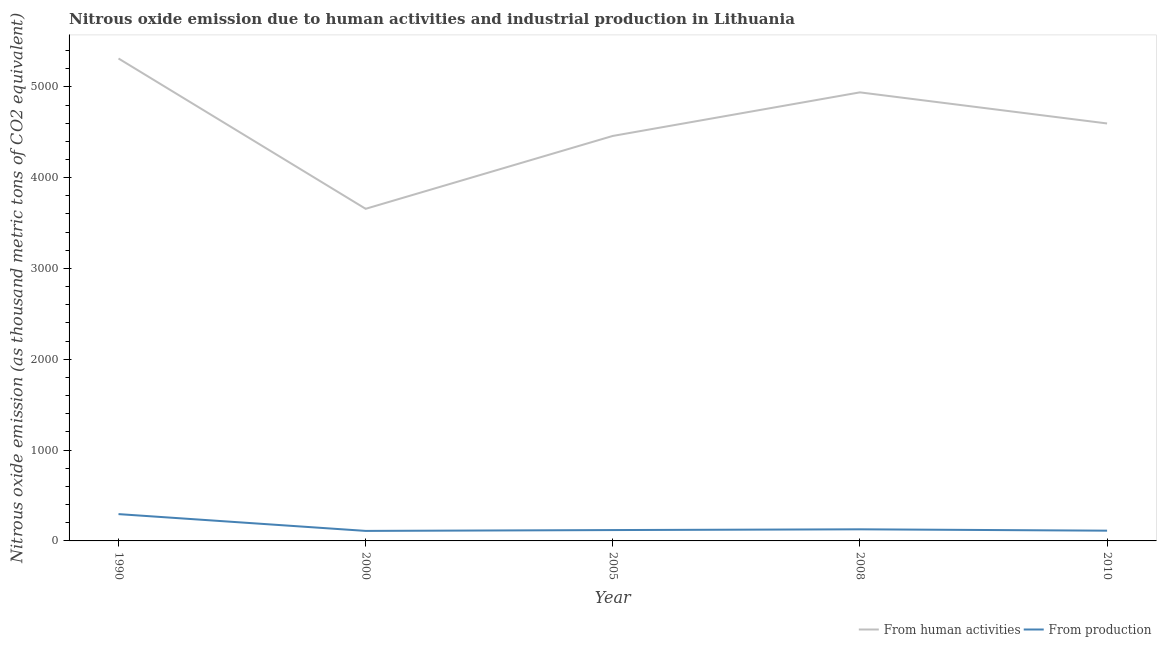How many different coloured lines are there?
Offer a terse response. 2. Does the line corresponding to amount of emissions generated from industries intersect with the line corresponding to amount of emissions from human activities?
Offer a terse response. No. Is the number of lines equal to the number of legend labels?
Keep it short and to the point. Yes. What is the amount of emissions from human activities in 2010?
Your response must be concise. 4596.8. Across all years, what is the maximum amount of emissions from human activities?
Keep it short and to the point. 5312.1. Across all years, what is the minimum amount of emissions generated from industries?
Offer a very short reply. 110.3. In which year was the amount of emissions from human activities maximum?
Give a very brief answer. 1990. What is the total amount of emissions from human activities in the graph?
Provide a succinct answer. 2.30e+04. What is the difference between the amount of emissions generated from industries in 2008 and the amount of emissions from human activities in 2005?
Your response must be concise. -4331.5. What is the average amount of emissions generated from industries per year?
Give a very brief answer. 153.16. In the year 2005, what is the difference between the amount of emissions from human activities and amount of emissions generated from industries?
Keep it short and to the point. 4339.8. What is the ratio of the amount of emissions generated from industries in 1990 to that in 2005?
Give a very brief answer. 2.47. Is the amount of emissions from human activities in 1990 less than that in 2008?
Provide a short and direct response. No. Is the difference between the amount of emissions from human activities in 2000 and 2010 greater than the difference between the amount of emissions generated from industries in 2000 and 2010?
Give a very brief answer. No. What is the difference between the highest and the second highest amount of emissions from human activities?
Keep it short and to the point. 372.9. What is the difference between the highest and the lowest amount of emissions generated from industries?
Your response must be concise. 184.9. Is the amount of emissions from human activities strictly greater than the amount of emissions generated from industries over the years?
Your answer should be compact. Yes. How many lines are there?
Your response must be concise. 2. How many years are there in the graph?
Your response must be concise. 5. What is the difference between two consecutive major ticks on the Y-axis?
Your response must be concise. 1000. Does the graph contain any zero values?
Provide a succinct answer. No. Where does the legend appear in the graph?
Keep it short and to the point. Bottom right. What is the title of the graph?
Your answer should be compact. Nitrous oxide emission due to human activities and industrial production in Lithuania. Does "Techinal cooperation" appear as one of the legend labels in the graph?
Make the answer very short. No. What is the label or title of the Y-axis?
Keep it short and to the point. Nitrous oxide emission (as thousand metric tons of CO2 equivalent). What is the Nitrous oxide emission (as thousand metric tons of CO2 equivalent) in From human activities in 1990?
Your answer should be compact. 5312.1. What is the Nitrous oxide emission (as thousand metric tons of CO2 equivalent) in From production in 1990?
Provide a succinct answer. 295.2. What is the Nitrous oxide emission (as thousand metric tons of CO2 equivalent) in From human activities in 2000?
Offer a terse response. 3657. What is the Nitrous oxide emission (as thousand metric tons of CO2 equivalent) in From production in 2000?
Keep it short and to the point. 110.3. What is the Nitrous oxide emission (as thousand metric tons of CO2 equivalent) in From human activities in 2005?
Your response must be concise. 4459.4. What is the Nitrous oxide emission (as thousand metric tons of CO2 equivalent) in From production in 2005?
Your answer should be compact. 119.6. What is the Nitrous oxide emission (as thousand metric tons of CO2 equivalent) in From human activities in 2008?
Offer a terse response. 4939.2. What is the Nitrous oxide emission (as thousand metric tons of CO2 equivalent) of From production in 2008?
Your answer should be compact. 127.9. What is the Nitrous oxide emission (as thousand metric tons of CO2 equivalent) in From human activities in 2010?
Provide a short and direct response. 4596.8. What is the Nitrous oxide emission (as thousand metric tons of CO2 equivalent) of From production in 2010?
Ensure brevity in your answer.  112.8. Across all years, what is the maximum Nitrous oxide emission (as thousand metric tons of CO2 equivalent) of From human activities?
Provide a succinct answer. 5312.1. Across all years, what is the maximum Nitrous oxide emission (as thousand metric tons of CO2 equivalent) in From production?
Your response must be concise. 295.2. Across all years, what is the minimum Nitrous oxide emission (as thousand metric tons of CO2 equivalent) of From human activities?
Offer a terse response. 3657. Across all years, what is the minimum Nitrous oxide emission (as thousand metric tons of CO2 equivalent) of From production?
Provide a short and direct response. 110.3. What is the total Nitrous oxide emission (as thousand metric tons of CO2 equivalent) in From human activities in the graph?
Your answer should be compact. 2.30e+04. What is the total Nitrous oxide emission (as thousand metric tons of CO2 equivalent) of From production in the graph?
Offer a very short reply. 765.8. What is the difference between the Nitrous oxide emission (as thousand metric tons of CO2 equivalent) of From human activities in 1990 and that in 2000?
Provide a short and direct response. 1655.1. What is the difference between the Nitrous oxide emission (as thousand metric tons of CO2 equivalent) of From production in 1990 and that in 2000?
Provide a short and direct response. 184.9. What is the difference between the Nitrous oxide emission (as thousand metric tons of CO2 equivalent) of From human activities in 1990 and that in 2005?
Make the answer very short. 852.7. What is the difference between the Nitrous oxide emission (as thousand metric tons of CO2 equivalent) of From production in 1990 and that in 2005?
Your response must be concise. 175.6. What is the difference between the Nitrous oxide emission (as thousand metric tons of CO2 equivalent) of From human activities in 1990 and that in 2008?
Provide a short and direct response. 372.9. What is the difference between the Nitrous oxide emission (as thousand metric tons of CO2 equivalent) in From production in 1990 and that in 2008?
Your response must be concise. 167.3. What is the difference between the Nitrous oxide emission (as thousand metric tons of CO2 equivalent) of From human activities in 1990 and that in 2010?
Your response must be concise. 715.3. What is the difference between the Nitrous oxide emission (as thousand metric tons of CO2 equivalent) in From production in 1990 and that in 2010?
Offer a terse response. 182.4. What is the difference between the Nitrous oxide emission (as thousand metric tons of CO2 equivalent) of From human activities in 2000 and that in 2005?
Your answer should be very brief. -802.4. What is the difference between the Nitrous oxide emission (as thousand metric tons of CO2 equivalent) in From human activities in 2000 and that in 2008?
Ensure brevity in your answer.  -1282.2. What is the difference between the Nitrous oxide emission (as thousand metric tons of CO2 equivalent) of From production in 2000 and that in 2008?
Your answer should be very brief. -17.6. What is the difference between the Nitrous oxide emission (as thousand metric tons of CO2 equivalent) in From human activities in 2000 and that in 2010?
Your answer should be very brief. -939.8. What is the difference between the Nitrous oxide emission (as thousand metric tons of CO2 equivalent) in From human activities in 2005 and that in 2008?
Make the answer very short. -479.8. What is the difference between the Nitrous oxide emission (as thousand metric tons of CO2 equivalent) of From human activities in 2005 and that in 2010?
Your answer should be compact. -137.4. What is the difference between the Nitrous oxide emission (as thousand metric tons of CO2 equivalent) in From human activities in 2008 and that in 2010?
Your response must be concise. 342.4. What is the difference between the Nitrous oxide emission (as thousand metric tons of CO2 equivalent) of From human activities in 1990 and the Nitrous oxide emission (as thousand metric tons of CO2 equivalent) of From production in 2000?
Provide a succinct answer. 5201.8. What is the difference between the Nitrous oxide emission (as thousand metric tons of CO2 equivalent) of From human activities in 1990 and the Nitrous oxide emission (as thousand metric tons of CO2 equivalent) of From production in 2005?
Ensure brevity in your answer.  5192.5. What is the difference between the Nitrous oxide emission (as thousand metric tons of CO2 equivalent) of From human activities in 1990 and the Nitrous oxide emission (as thousand metric tons of CO2 equivalent) of From production in 2008?
Make the answer very short. 5184.2. What is the difference between the Nitrous oxide emission (as thousand metric tons of CO2 equivalent) in From human activities in 1990 and the Nitrous oxide emission (as thousand metric tons of CO2 equivalent) in From production in 2010?
Offer a terse response. 5199.3. What is the difference between the Nitrous oxide emission (as thousand metric tons of CO2 equivalent) in From human activities in 2000 and the Nitrous oxide emission (as thousand metric tons of CO2 equivalent) in From production in 2005?
Offer a terse response. 3537.4. What is the difference between the Nitrous oxide emission (as thousand metric tons of CO2 equivalent) in From human activities in 2000 and the Nitrous oxide emission (as thousand metric tons of CO2 equivalent) in From production in 2008?
Your answer should be compact. 3529.1. What is the difference between the Nitrous oxide emission (as thousand metric tons of CO2 equivalent) in From human activities in 2000 and the Nitrous oxide emission (as thousand metric tons of CO2 equivalent) in From production in 2010?
Make the answer very short. 3544.2. What is the difference between the Nitrous oxide emission (as thousand metric tons of CO2 equivalent) in From human activities in 2005 and the Nitrous oxide emission (as thousand metric tons of CO2 equivalent) in From production in 2008?
Ensure brevity in your answer.  4331.5. What is the difference between the Nitrous oxide emission (as thousand metric tons of CO2 equivalent) in From human activities in 2005 and the Nitrous oxide emission (as thousand metric tons of CO2 equivalent) in From production in 2010?
Your response must be concise. 4346.6. What is the difference between the Nitrous oxide emission (as thousand metric tons of CO2 equivalent) in From human activities in 2008 and the Nitrous oxide emission (as thousand metric tons of CO2 equivalent) in From production in 2010?
Provide a short and direct response. 4826.4. What is the average Nitrous oxide emission (as thousand metric tons of CO2 equivalent) in From human activities per year?
Your answer should be very brief. 4592.9. What is the average Nitrous oxide emission (as thousand metric tons of CO2 equivalent) of From production per year?
Ensure brevity in your answer.  153.16. In the year 1990, what is the difference between the Nitrous oxide emission (as thousand metric tons of CO2 equivalent) of From human activities and Nitrous oxide emission (as thousand metric tons of CO2 equivalent) of From production?
Offer a very short reply. 5016.9. In the year 2000, what is the difference between the Nitrous oxide emission (as thousand metric tons of CO2 equivalent) in From human activities and Nitrous oxide emission (as thousand metric tons of CO2 equivalent) in From production?
Offer a terse response. 3546.7. In the year 2005, what is the difference between the Nitrous oxide emission (as thousand metric tons of CO2 equivalent) of From human activities and Nitrous oxide emission (as thousand metric tons of CO2 equivalent) of From production?
Offer a very short reply. 4339.8. In the year 2008, what is the difference between the Nitrous oxide emission (as thousand metric tons of CO2 equivalent) of From human activities and Nitrous oxide emission (as thousand metric tons of CO2 equivalent) of From production?
Your answer should be very brief. 4811.3. In the year 2010, what is the difference between the Nitrous oxide emission (as thousand metric tons of CO2 equivalent) of From human activities and Nitrous oxide emission (as thousand metric tons of CO2 equivalent) of From production?
Make the answer very short. 4484. What is the ratio of the Nitrous oxide emission (as thousand metric tons of CO2 equivalent) of From human activities in 1990 to that in 2000?
Your answer should be very brief. 1.45. What is the ratio of the Nitrous oxide emission (as thousand metric tons of CO2 equivalent) in From production in 1990 to that in 2000?
Make the answer very short. 2.68. What is the ratio of the Nitrous oxide emission (as thousand metric tons of CO2 equivalent) in From human activities in 1990 to that in 2005?
Ensure brevity in your answer.  1.19. What is the ratio of the Nitrous oxide emission (as thousand metric tons of CO2 equivalent) in From production in 1990 to that in 2005?
Offer a terse response. 2.47. What is the ratio of the Nitrous oxide emission (as thousand metric tons of CO2 equivalent) in From human activities in 1990 to that in 2008?
Give a very brief answer. 1.08. What is the ratio of the Nitrous oxide emission (as thousand metric tons of CO2 equivalent) in From production in 1990 to that in 2008?
Offer a terse response. 2.31. What is the ratio of the Nitrous oxide emission (as thousand metric tons of CO2 equivalent) of From human activities in 1990 to that in 2010?
Offer a very short reply. 1.16. What is the ratio of the Nitrous oxide emission (as thousand metric tons of CO2 equivalent) of From production in 1990 to that in 2010?
Your response must be concise. 2.62. What is the ratio of the Nitrous oxide emission (as thousand metric tons of CO2 equivalent) of From human activities in 2000 to that in 2005?
Your response must be concise. 0.82. What is the ratio of the Nitrous oxide emission (as thousand metric tons of CO2 equivalent) in From production in 2000 to that in 2005?
Provide a short and direct response. 0.92. What is the ratio of the Nitrous oxide emission (as thousand metric tons of CO2 equivalent) in From human activities in 2000 to that in 2008?
Your answer should be very brief. 0.74. What is the ratio of the Nitrous oxide emission (as thousand metric tons of CO2 equivalent) of From production in 2000 to that in 2008?
Provide a succinct answer. 0.86. What is the ratio of the Nitrous oxide emission (as thousand metric tons of CO2 equivalent) of From human activities in 2000 to that in 2010?
Offer a terse response. 0.8. What is the ratio of the Nitrous oxide emission (as thousand metric tons of CO2 equivalent) of From production in 2000 to that in 2010?
Keep it short and to the point. 0.98. What is the ratio of the Nitrous oxide emission (as thousand metric tons of CO2 equivalent) in From human activities in 2005 to that in 2008?
Your answer should be compact. 0.9. What is the ratio of the Nitrous oxide emission (as thousand metric tons of CO2 equivalent) in From production in 2005 to that in 2008?
Offer a very short reply. 0.94. What is the ratio of the Nitrous oxide emission (as thousand metric tons of CO2 equivalent) in From human activities in 2005 to that in 2010?
Ensure brevity in your answer.  0.97. What is the ratio of the Nitrous oxide emission (as thousand metric tons of CO2 equivalent) of From production in 2005 to that in 2010?
Offer a terse response. 1.06. What is the ratio of the Nitrous oxide emission (as thousand metric tons of CO2 equivalent) of From human activities in 2008 to that in 2010?
Offer a very short reply. 1.07. What is the ratio of the Nitrous oxide emission (as thousand metric tons of CO2 equivalent) of From production in 2008 to that in 2010?
Your response must be concise. 1.13. What is the difference between the highest and the second highest Nitrous oxide emission (as thousand metric tons of CO2 equivalent) in From human activities?
Provide a short and direct response. 372.9. What is the difference between the highest and the second highest Nitrous oxide emission (as thousand metric tons of CO2 equivalent) of From production?
Provide a short and direct response. 167.3. What is the difference between the highest and the lowest Nitrous oxide emission (as thousand metric tons of CO2 equivalent) in From human activities?
Provide a short and direct response. 1655.1. What is the difference between the highest and the lowest Nitrous oxide emission (as thousand metric tons of CO2 equivalent) of From production?
Your response must be concise. 184.9. 